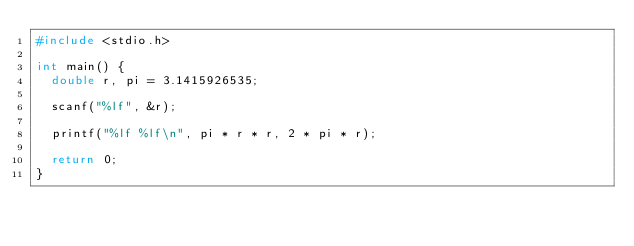<code> <loc_0><loc_0><loc_500><loc_500><_C_>#include <stdio.h>

int main() {
  double r, pi = 3.1415926535;

  scanf("%lf", &r);

  printf("%lf %lf\n", pi * r * r, 2 * pi * r);

  return 0;
}</code> 